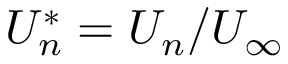<formula> <loc_0><loc_0><loc_500><loc_500>U _ { n } ^ { * } = U _ { n } / U _ { \infty }</formula> 